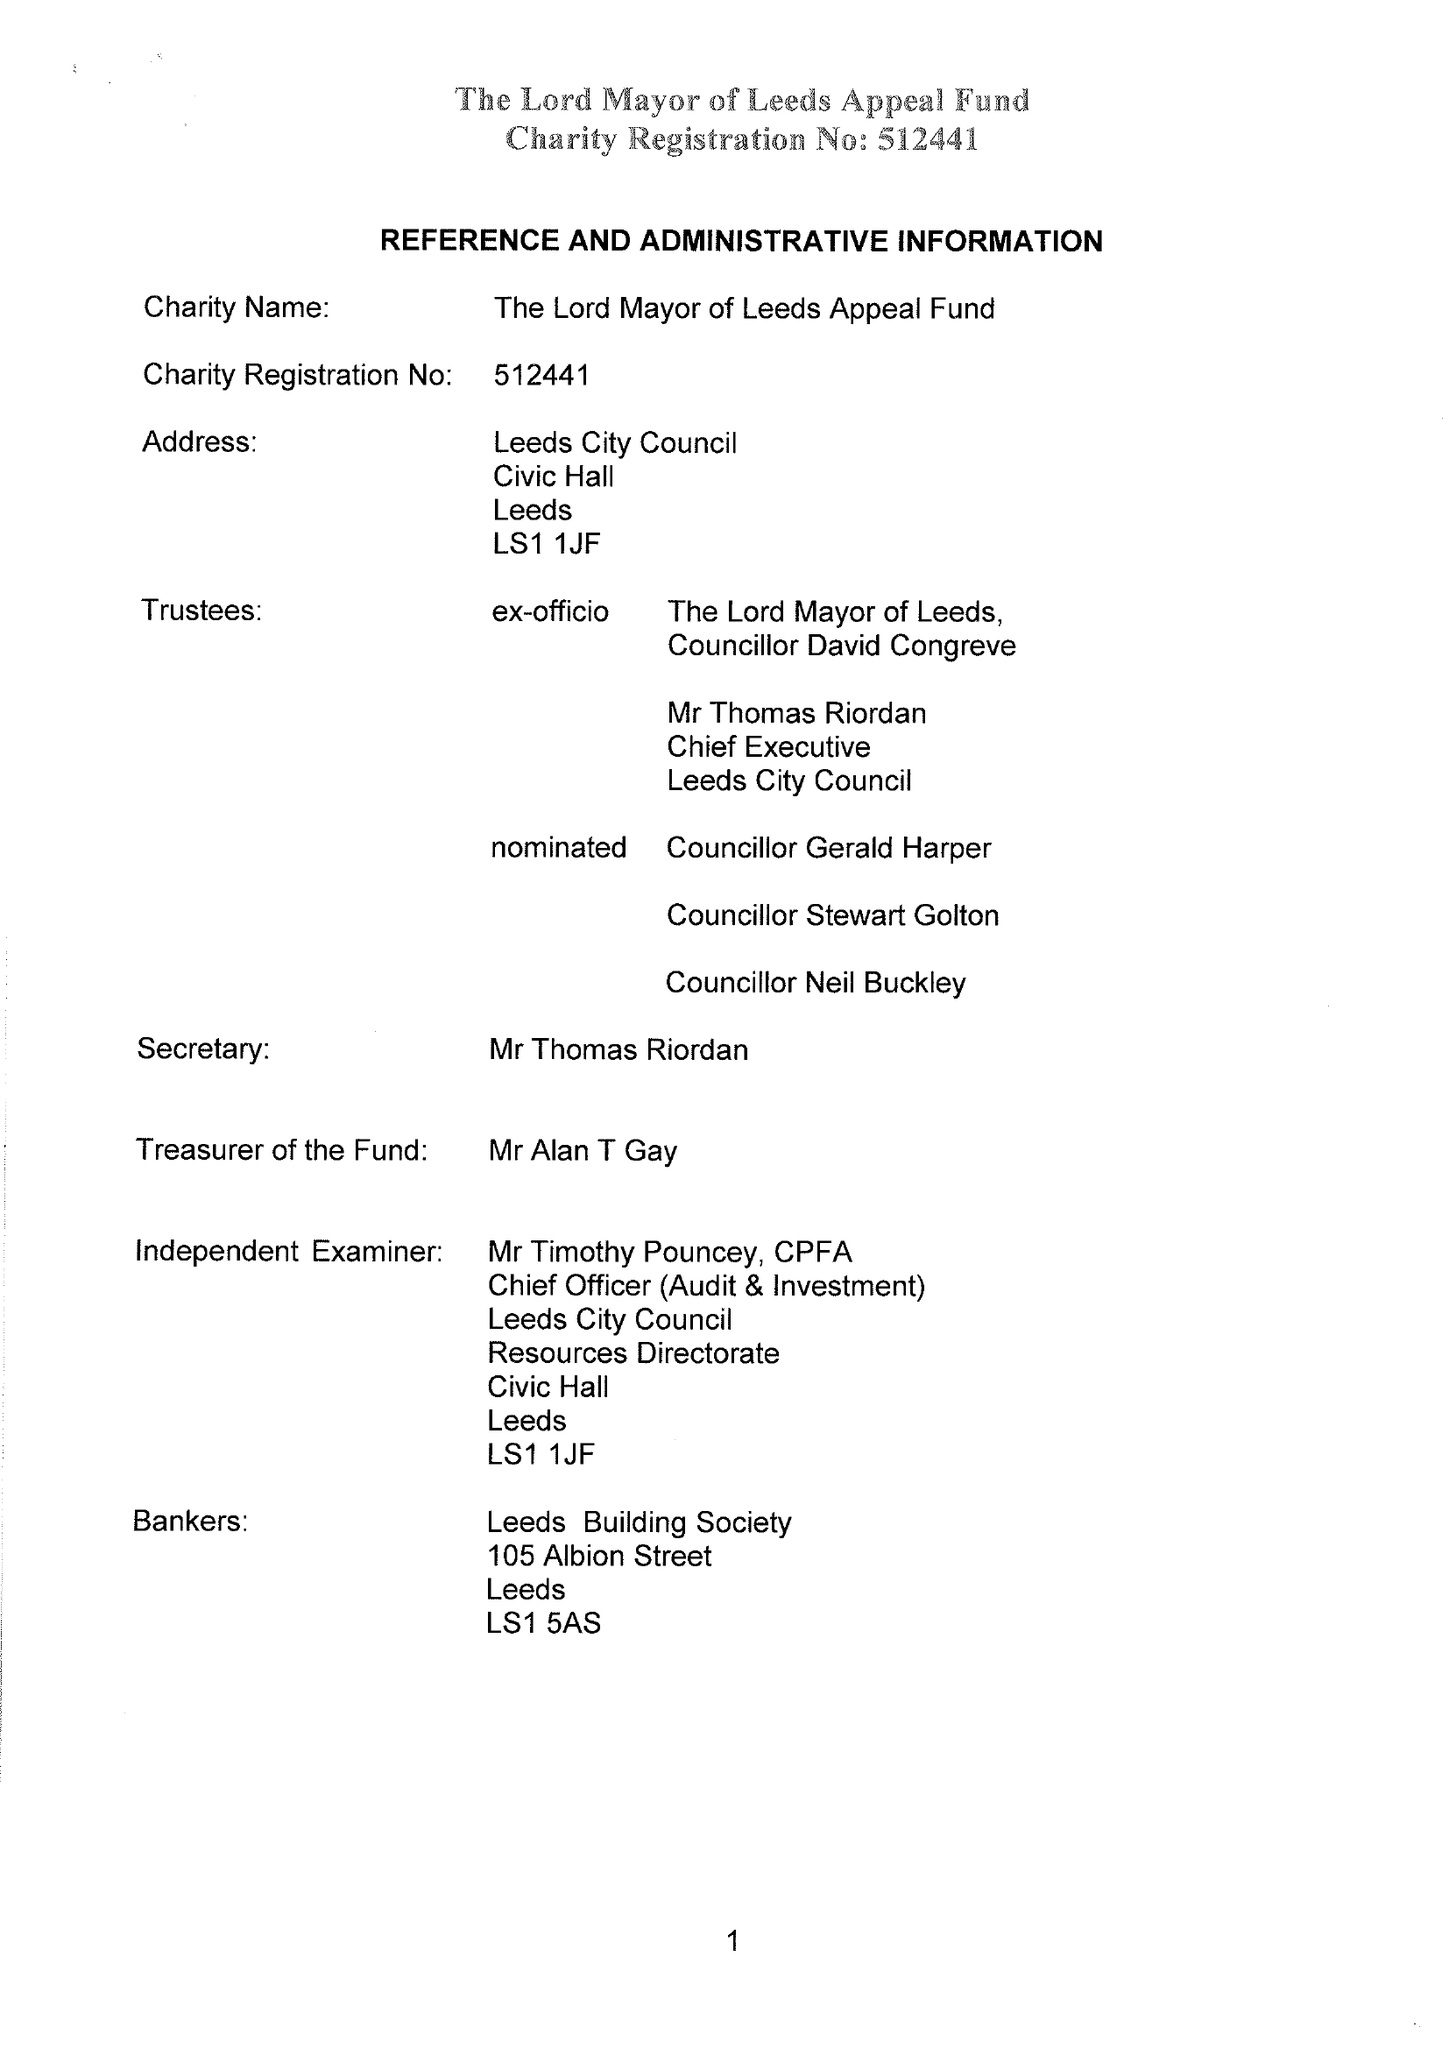What is the value for the income_annually_in_british_pounds?
Answer the question using a single word or phrase. 27143.00 